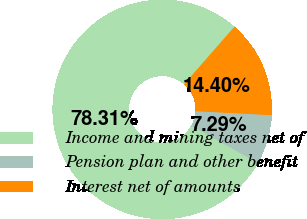Convert chart to OTSL. <chart><loc_0><loc_0><loc_500><loc_500><pie_chart><fcel>Income and mining taxes net of<fcel>Pension plan and other benefit<fcel>Interest net of amounts<nl><fcel>78.31%<fcel>7.29%<fcel>14.4%<nl></chart> 